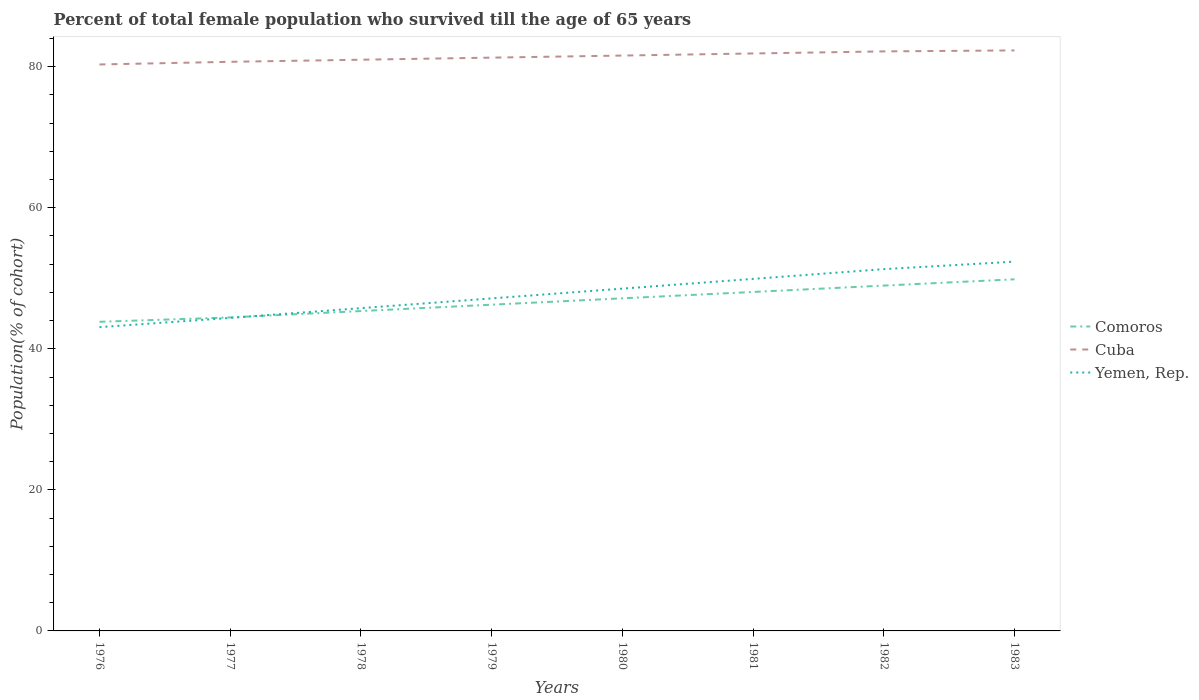Does the line corresponding to Cuba intersect with the line corresponding to Yemen, Rep.?
Provide a short and direct response. No. Across all years, what is the maximum percentage of total female population who survived till the age of 65 years in Comoros?
Offer a terse response. 43.83. In which year was the percentage of total female population who survived till the age of 65 years in Yemen, Rep. maximum?
Offer a very short reply. 1976. What is the total percentage of total female population who survived till the age of 65 years in Cuba in the graph?
Your answer should be compact. -0.3. What is the difference between the highest and the second highest percentage of total female population who survived till the age of 65 years in Comoros?
Your answer should be very brief. 6.03. What is the difference between two consecutive major ticks on the Y-axis?
Make the answer very short. 20. Are the values on the major ticks of Y-axis written in scientific E-notation?
Offer a very short reply. No. Does the graph contain grids?
Provide a succinct answer. No. Where does the legend appear in the graph?
Provide a succinct answer. Center right. How are the legend labels stacked?
Your answer should be very brief. Vertical. What is the title of the graph?
Your response must be concise. Percent of total female population who survived till the age of 65 years. Does "Tonga" appear as one of the legend labels in the graph?
Your answer should be compact. No. What is the label or title of the Y-axis?
Ensure brevity in your answer.  Population(% of cohort). What is the Population(% of cohort) of Comoros in 1976?
Offer a very short reply. 43.83. What is the Population(% of cohort) in Cuba in 1976?
Provide a succinct answer. 80.31. What is the Population(% of cohort) of Yemen, Rep. in 1976?
Provide a succinct answer. 43.07. What is the Population(% of cohort) of Comoros in 1977?
Make the answer very short. 44.45. What is the Population(% of cohort) of Cuba in 1977?
Ensure brevity in your answer.  80.69. What is the Population(% of cohort) of Yemen, Rep. in 1977?
Your response must be concise. 44.38. What is the Population(% of cohort) in Comoros in 1978?
Your answer should be very brief. 45.35. What is the Population(% of cohort) in Cuba in 1978?
Ensure brevity in your answer.  80.99. What is the Population(% of cohort) in Yemen, Rep. in 1978?
Your answer should be compact. 45.76. What is the Population(% of cohort) in Comoros in 1979?
Offer a terse response. 46.25. What is the Population(% of cohort) in Cuba in 1979?
Your response must be concise. 81.28. What is the Population(% of cohort) of Yemen, Rep. in 1979?
Ensure brevity in your answer.  47.15. What is the Population(% of cohort) in Comoros in 1980?
Offer a terse response. 47.16. What is the Population(% of cohort) in Cuba in 1980?
Your answer should be very brief. 81.58. What is the Population(% of cohort) of Yemen, Rep. in 1980?
Ensure brevity in your answer.  48.53. What is the Population(% of cohort) of Comoros in 1981?
Make the answer very short. 48.06. What is the Population(% of cohort) in Cuba in 1981?
Provide a short and direct response. 81.87. What is the Population(% of cohort) of Yemen, Rep. in 1981?
Your answer should be very brief. 49.91. What is the Population(% of cohort) of Comoros in 1982?
Provide a succinct answer. 48.96. What is the Population(% of cohort) of Cuba in 1982?
Provide a short and direct response. 82.17. What is the Population(% of cohort) in Yemen, Rep. in 1982?
Offer a very short reply. 51.3. What is the Population(% of cohort) of Comoros in 1983?
Offer a very short reply. 49.85. What is the Population(% of cohort) of Cuba in 1983?
Keep it short and to the point. 82.31. What is the Population(% of cohort) in Yemen, Rep. in 1983?
Offer a very short reply. 52.35. Across all years, what is the maximum Population(% of cohort) in Comoros?
Keep it short and to the point. 49.85. Across all years, what is the maximum Population(% of cohort) in Cuba?
Your answer should be compact. 82.31. Across all years, what is the maximum Population(% of cohort) of Yemen, Rep.?
Ensure brevity in your answer.  52.35. Across all years, what is the minimum Population(% of cohort) of Comoros?
Offer a terse response. 43.83. Across all years, what is the minimum Population(% of cohort) in Cuba?
Your answer should be compact. 80.31. Across all years, what is the minimum Population(% of cohort) of Yemen, Rep.?
Give a very brief answer. 43.07. What is the total Population(% of cohort) in Comoros in the graph?
Give a very brief answer. 373.92. What is the total Population(% of cohort) of Cuba in the graph?
Offer a terse response. 651.2. What is the total Population(% of cohort) of Yemen, Rep. in the graph?
Give a very brief answer. 382.45. What is the difference between the Population(% of cohort) of Comoros in 1976 and that in 1977?
Your answer should be very brief. -0.62. What is the difference between the Population(% of cohort) in Cuba in 1976 and that in 1977?
Offer a terse response. -0.38. What is the difference between the Population(% of cohort) of Yemen, Rep. in 1976 and that in 1977?
Keep it short and to the point. -1.31. What is the difference between the Population(% of cohort) of Comoros in 1976 and that in 1978?
Provide a succinct answer. -1.52. What is the difference between the Population(% of cohort) of Cuba in 1976 and that in 1978?
Keep it short and to the point. -0.67. What is the difference between the Population(% of cohort) of Yemen, Rep. in 1976 and that in 1978?
Give a very brief answer. -2.69. What is the difference between the Population(% of cohort) in Comoros in 1976 and that in 1979?
Ensure brevity in your answer.  -2.43. What is the difference between the Population(% of cohort) of Cuba in 1976 and that in 1979?
Your response must be concise. -0.97. What is the difference between the Population(% of cohort) of Yemen, Rep. in 1976 and that in 1979?
Provide a succinct answer. -4.08. What is the difference between the Population(% of cohort) in Comoros in 1976 and that in 1980?
Give a very brief answer. -3.33. What is the difference between the Population(% of cohort) of Cuba in 1976 and that in 1980?
Provide a short and direct response. -1.26. What is the difference between the Population(% of cohort) of Yemen, Rep. in 1976 and that in 1980?
Keep it short and to the point. -5.46. What is the difference between the Population(% of cohort) in Comoros in 1976 and that in 1981?
Ensure brevity in your answer.  -4.23. What is the difference between the Population(% of cohort) in Cuba in 1976 and that in 1981?
Offer a very short reply. -1.56. What is the difference between the Population(% of cohort) of Yemen, Rep. in 1976 and that in 1981?
Your response must be concise. -6.84. What is the difference between the Population(% of cohort) in Comoros in 1976 and that in 1982?
Your response must be concise. -5.13. What is the difference between the Population(% of cohort) of Cuba in 1976 and that in 1982?
Keep it short and to the point. -1.85. What is the difference between the Population(% of cohort) of Yemen, Rep. in 1976 and that in 1982?
Provide a short and direct response. -8.23. What is the difference between the Population(% of cohort) of Comoros in 1976 and that in 1983?
Make the answer very short. -6.03. What is the difference between the Population(% of cohort) in Cuba in 1976 and that in 1983?
Ensure brevity in your answer.  -1.99. What is the difference between the Population(% of cohort) in Yemen, Rep. in 1976 and that in 1983?
Give a very brief answer. -9.28. What is the difference between the Population(% of cohort) of Comoros in 1977 and that in 1978?
Your response must be concise. -0.9. What is the difference between the Population(% of cohort) in Cuba in 1977 and that in 1978?
Make the answer very short. -0.3. What is the difference between the Population(% of cohort) of Yemen, Rep. in 1977 and that in 1978?
Your answer should be very brief. -1.38. What is the difference between the Population(% of cohort) in Comoros in 1977 and that in 1979?
Your answer should be very brief. -1.81. What is the difference between the Population(% of cohort) of Cuba in 1977 and that in 1979?
Your answer should be compact. -0.59. What is the difference between the Population(% of cohort) in Yemen, Rep. in 1977 and that in 1979?
Your answer should be compact. -2.77. What is the difference between the Population(% of cohort) of Comoros in 1977 and that in 1980?
Offer a very short reply. -2.71. What is the difference between the Population(% of cohort) in Cuba in 1977 and that in 1980?
Keep it short and to the point. -0.89. What is the difference between the Population(% of cohort) of Yemen, Rep. in 1977 and that in 1980?
Offer a terse response. -4.15. What is the difference between the Population(% of cohort) of Comoros in 1977 and that in 1981?
Your response must be concise. -3.61. What is the difference between the Population(% of cohort) of Cuba in 1977 and that in 1981?
Ensure brevity in your answer.  -1.18. What is the difference between the Population(% of cohort) of Yemen, Rep. in 1977 and that in 1981?
Ensure brevity in your answer.  -5.53. What is the difference between the Population(% of cohort) in Comoros in 1977 and that in 1982?
Offer a very short reply. -4.51. What is the difference between the Population(% of cohort) in Cuba in 1977 and that in 1982?
Make the answer very short. -1.48. What is the difference between the Population(% of cohort) in Yemen, Rep. in 1977 and that in 1982?
Ensure brevity in your answer.  -6.92. What is the difference between the Population(% of cohort) in Comoros in 1977 and that in 1983?
Your answer should be compact. -5.41. What is the difference between the Population(% of cohort) of Cuba in 1977 and that in 1983?
Provide a short and direct response. -1.62. What is the difference between the Population(% of cohort) in Yemen, Rep. in 1977 and that in 1983?
Your response must be concise. -7.97. What is the difference between the Population(% of cohort) of Comoros in 1978 and that in 1979?
Keep it short and to the point. -0.9. What is the difference between the Population(% of cohort) in Cuba in 1978 and that in 1979?
Give a very brief answer. -0.3. What is the difference between the Population(% of cohort) in Yemen, Rep. in 1978 and that in 1979?
Make the answer very short. -1.38. What is the difference between the Population(% of cohort) of Comoros in 1978 and that in 1980?
Offer a terse response. -1.81. What is the difference between the Population(% of cohort) in Cuba in 1978 and that in 1980?
Keep it short and to the point. -0.59. What is the difference between the Population(% of cohort) in Yemen, Rep. in 1978 and that in 1980?
Offer a very short reply. -2.77. What is the difference between the Population(% of cohort) of Comoros in 1978 and that in 1981?
Offer a very short reply. -2.71. What is the difference between the Population(% of cohort) of Cuba in 1978 and that in 1981?
Your answer should be compact. -0.89. What is the difference between the Population(% of cohort) in Yemen, Rep. in 1978 and that in 1981?
Your answer should be very brief. -4.15. What is the difference between the Population(% of cohort) of Comoros in 1978 and that in 1982?
Keep it short and to the point. -3.61. What is the difference between the Population(% of cohort) in Cuba in 1978 and that in 1982?
Provide a succinct answer. -1.18. What is the difference between the Population(% of cohort) in Yemen, Rep. in 1978 and that in 1982?
Keep it short and to the point. -5.53. What is the difference between the Population(% of cohort) of Comoros in 1978 and that in 1983?
Make the answer very short. -4.5. What is the difference between the Population(% of cohort) in Cuba in 1978 and that in 1983?
Your answer should be very brief. -1.32. What is the difference between the Population(% of cohort) in Yemen, Rep. in 1978 and that in 1983?
Keep it short and to the point. -6.59. What is the difference between the Population(% of cohort) in Comoros in 1979 and that in 1980?
Your response must be concise. -0.9. What is the difference between the Population(% of cohort) of Cuba in 1979 and that in 1980?
Your response must be concise. -0.3. What is the difference between the Population(% of cohort) in Yemen, Rep. in 1979 and that in 1980?
Give a very brief answer. -1.38. What is the difference between the Population(% of cohort) of Comoros in 1979 and that in 1981?
Ensure brevity in your answer.  -1.81. What is the difference between the Population(% of cohort) of Cuba in 1979 and that in 1981?
Ensure brevity in your answer.  -0.59. What is the difference between the Population(% of cohort) in Yemen, Rep. in 1979 and that in 1981?
Make the answer very short. -2.77. What is the difference between the Population(% of cohort) of Comoros in 1979 and that in 1982?
Give a very brief answer. -2.71. What is the difference between the Population(% of cohort) in Cuba in 1979 and that in 1982?
Your answer should be very brief. -0.89. What is the difference between the Population(% of cohort) in Yemen, Rep. in 1979 and that in 1982?
Keep it short and to the point. -4.15. What is the difference between the Population(% of cohort) in Comoros in 1979 and that in 1983?
Provide a short and direct response. -3.6. What is the difference between the Population(% of cohort) of Cuba in 1979 and that in 1983?
Keep it short and to the point. -1.02. What is the difference between the Population(% of cohort) of Yemen, Rep. in 1979 and that in 1983?
Offer a very short reply. -5.21. What is the difference between the Population(% of cohort) in Comoros in 1980 and that in 1981?
Provide a succinct answer. -0.9. What is the difference between the Population(% of cohort) of Cuba in 1980 and that in 1981?
Give a very brief answer. -0.3. What is the difference between the Population(% of cohort) of Yemen, Rep. in 1980 and that in 1981?
Your answer should be very brief. -1.38. What is the difference between the Population(% of cohort) in Comoros in 1980 and that in 1982?
Give a very brief answer. -1.81. What is the difference between the Population(% of cohort) in Cuba in 1980 and that in 1982?
Make the answer very short. -0.59. What is the difference between the Population(% of cohort) of Yemen, Rep. in 1980 and that in 1982?
Keep it short and to the point. -2.77. What is the difference between the Population(% of cohort) in Comoros in 1980 and that in 1983?
Your answer should be compact. -2.7. What is the difference between the Population(% of cohort) in Cuba in 1980 and that in 1983?
Offer a terse response. -0.73. What is the difference between the Population(% of cohort) in Yemen, Rep. in 1980 and that in 1983?
Your answer should be very brief. -3.82. What is the difference between the Population(% of cohort) of Comoros in 1981 and that in 1982?
Offer a very short reply. -0.9. What is the difference between the Population(% of cohort) in Cuba in 1981 and that in 1982?
Give a very brief answer. -0.3. What is the difference between the Population(% of cohort) in Yemen, Rep. in 1981 and that in 1982?
Give a very brief answer. -1.38. What is the difference between the Population(% of cohort) in Comoros in 1981 and that in 1983?
Give a very brief answer. -1.8. What is the difference between the Population(% of cohort) of Cuba in 1981 and that in 1983?
Offer a very short reply. -0.43. What is the difference between the Population(% of cohort) of Yemen, Rep. in 1981 and that in 1983?
Offer a very short reply. -2.44. What is the difference between the Population(% of cohort) of Comoros in 1982 and that in 1983?
Provide a short and direct response. -0.89. What is the difference between the Population(% of cohort) in Cuba in 1982 and that in 1983?
Give a very brief answer. -0.14. What is the difference between the Population(% of cohort) in Yemen, Rep. in 1982 and that in 1983?
Make the answer very short. -1.06. What is the difference between the Population(% of cohort) in Comoros in 1976 and the Population(% of cohort) in Cuba in 1977?
Provide a short and direct response. -36.86. What is the difference between the Population(% of cohort) of Comoros in 1976 and the Population(% of cohort) of Yemen, Rep. in 1977?
Keep it short and to the point. -0.55. What is the difference between the Population(% of cohort) in Cuba in 1976 and the Population(% of cohort) in Yemen, Rep. in 1977?
Your answer should be very brief. 35.93. What is the difference between the Population(% of cohort) of Comoros in 1976 and the Population(% of cohort) of Cuba in 1978?
Your response must be concise. -37.16. What is the difference between the Population(% of cohort) in Comoros in 1976 and the Population(% of cohort) in Yemen, Rep. in 1978?
Keep it short and to the point. -1.94. What is the difference between the Population(% of cohort) in Cuba in 1976 and the Population(% of cohort) in Yemen, Rep. in 1978?
Offer a terse response. 34.55. What is the difference between the Population(% of cohort) in Comoros in 1976 and the Population(% of cohort) in Cuba in 1979?
Provide a succinct answer. -37.45. What is the difference between the Population(% of cohort) in Comoros in 1976 and the Population(% of cohort) in Yemen, Rep. in 1979?
Provide a succinct answer. -3.32. What is the difference between the Population(% of cohort) in Cuba in 1976 and the Population(% of cohort) in Yemen, Rep. in 1979?
Provide a succinct answer. 33.17. What is the difference between the Population(% of cohort) in Comoros in 1976 and the Population(% of cohort) in Cuba in 1980?
Your answer should be very brief. -37.75. What is the difference between the Population(% of cohort) in Comoros in 1976 and the Population(% of cohort) in Yemen, Rep. in 1980?
Provide a succinct answer. -4.7. What is the difference between the Population(% of cohort) of Cuba in 1976 and the Population(% of cohort) of Yemen, Rep. in 1980?
Offer a terse response. 31.78. What is the difference between the Population(% of cohort) in Comoros in 1976 and the Population(% of cohort) in Cuba in 1981?
Your answer should be compact. -38.04. What is the difference between the Population(% of cohort) in Comoros in 1976 and the Population(% of cohort) in Yemen, Rep. in 1981?
Make the answer very short. -6.09. What is the difference between the Population(% of cohort) of Cuba in 1976 and the Population(% of cohort) of Yemen, Rep. in 1981?
Offer a very short reply. 30.4. What is the difference between the Population(% of cohort) in Comoros in 1976 and the Population(% of cohort) in Cuba in 1982?
Keep it short and to the point. -38.34. What is the difference between the Population(% of cohort) in Comoros in 1976 and the Population(% of cohort) in Yemen, Rep. in 1982?
Provide a succinct answer. -7.47. What is the difference between the Population(% of cohort) in Cuba in 1976 and the Population(% of cohort) in Yemen, Rep. in 1982?
Provide a succinct answer. 29.02. What is the difference between the Population(% of cohort) of Comoros in 1976 and the Population(% of cohort) of Cuba in 1983?
Your answer should be very brief. -38.48. What is the difference between the Population(% of cohort) in Comoros in 1976 and the Population(% of cohort) in Yemen, Rep. in 1983?
Keep it short and to the point. -8.53. What is the difference between the Population(% of cohort) in Cuba in 1976 and the Population(% of cohort) in Yemen, Rep. in 1983?
Ensure brevity in your answer.  27.96. What is the difference between the Population(% of cohort) in Comoros in 1977 and the Population(% of cohort) in Cuba in 1978?
Your answer should be compact. -36.54. What is the difference between the Population(% of cohort) in Comoros in 1977 and the Population(% of cohort) in Yemen, Rep. in 1978?
Offer a terse response. -1.31. What is the difference between the Population(% of cohort) in Cuba in 1977 and the Population(% of cohort) in Yemen, Rep. in 1978?
Keep it short and to the point. 34.93. What is the difference between the Population(% of cohort) in Comoros in 1977 and the Population(% of cohort) in Cuba in 1979?
Make the answer very short. -36.83. What is the difference between the Population(% of cohort) in Comoros in 1977 and the Population(% of cohort) in Yemen, Rep. in 1979?
Your answer should be compact. -2.7. What is the difference between the Population(% of cohort) of Cuba in 1977 and the Population(% of cohort) of Yemen, Rep. in 1979?
Make the answer very short. 33.54. What is the difference between the Population(% of cohort) in Comoros in 1977 and the Population(% of cohort) in Cuba in 1980?
Keep it short and to the point. -37.13. What is the difference between the Population(% of cohort) of Comoros in 1977 and the Population(% of cohort) of Yemen, Rep. in 1980?
Your answer should be compact. -4.08. What is the difference between the Population(% of cohort) in Cuba in 1977 and the Population(% of cohort) in Yemen, Rep. in 1980?
Your response must be concise. 32.16. What is the difference between the Population(% of cohort) in Comoros in 1977 and the Population(% of cohort) in Cuba in 1981?
Keep it short and to the point. -37.42. What is the difference between the Population(% of cohort) of Comoros in 1977 and the Population(% of cohort) of Yemen, Rep. in 1981?
Your answer should be very brief. -5.46. What is the difference between the Population(% of cohort) in Cuba in 1977 and the Population(% of cohort) in Yemen, Rep. in 1981?
Make the answer very short. 30.78. What is the difference between the Population(% of cohort) in Comoros in 1977 and the Population(% of cohort) in Cuba in 1982?
Offer a terse response. -37.72. What is the difference between the Population(% of cohort) in Comoros in 1977 and the Population(% of cohort) in Yemen, Rep. in 1982?
Your answer should be compact. -6.85. What is the difference between the Population(% of cohort) of Cuba in 1977 and the Population(% of cohort) of Yemen, Rep. in 1982?
Offer a very short reply. 29.39. What is the difference between the Population(% of cohort) of Comoros in 1977 and the Population(% of cohort) of Cuba in 1983?
Offer a terse response. -37.86. What is the difference between the Population(% of cohort) in Comoros in 1977 and the Population(% of cohort) in Yemen, Rep. in 1983?
Make the answer very short. -7.9. What is the difference between the Population(% of cohort) of Cuba in 1977 and the Population(% of cohort) of Yemen, Rep. in 1983?
Your response must be concise. 28.34. What is the difference between the Population(% of cohort) in Comoros in 1978 and the Population(% of cohort) in Cuba in 1979?
Ensure brevity in your answer.  -35.93. What is the difference between the Population(% of cohort) of Comoros in 1978 and the Population(% of cohort) of Yemen, Rep. in 1979?
Offer a very short reply. -1.79. What is the difference between the Population(% of cohort) of Cuba in 1978 and the Population(% of cohort) of Yemen, Rep. in 1979?
Make the answer very short. 33.84. What is the difference between the Population(% of cohort) of Comoros in 1978 and the Population(% of cohort) of Cuba in 1980?
Offer a terse response. -36.23. What is the difference between the Population(% of cohort) of Comoros in 1978 and the Population(% of cohort) of Yemen, Rep. in 1980?
Provide a short and direct response. -3.18. What is the difference between the Population(% of cohort) of Cuba in 1978 and the Population(% of cohort) of Yemen, Rep. in 1980?
Offer a terse response. 32.46. What is the difference between the Population(% of cohort) in Comoros in 1978 and the Population(% of cohort) in Cuba in 1981?
Provide a short and direct response. -36.52. What is the difference between the Population(% of cohort) in Comoros in 1978 and the Population(% of cohort) in Yemen, Rep. in 1981?
Ensure brevity in your answer.  -4.56. What is the difference between the Population(% of cohort) of Cuba in 1978 and the Population(% of cohort) of Yemen, Rep. in 1981?
Your response must be concise. 31.07. What is the difference between the Population(% of cohort) in Comoros in 1978 and the Population(% of cohort) in Cuba in 1982?
Offer a terse response. -36.82. What is the difference between the Population(% of cohort) in Comoros in 1978 and the Population(% of cohort) in Yemen, Rep. in 1982?
Your answer should be very brief. -5.94. What is the difference between the Population(% of cohort) in Cuba in 1978 and the Population(% of cohort) in Yemen, Rep. in 1982?
Provide a succinct answer. 29.69. What is the difference between the Population(% of cohort) of Comoros in 1978 and the Population(% of cohort) of Cuba in 1983?
Give a very brief answer. -36.95. What is the difference between the Population(% of cohort) in Comoros in 1978 and the Population(% of cohort) in Yemen, Rep. in 1983?
Provide a short and direct response. -7. What is the difference between the Population(% of cohort) in Cuba in 1978 and the Population(% of cohort) in Yemen, Rep. in 1983?
Give a very brief answer. 28.63. What is the difference between the Population(% of cohort) in Comoros in 1979 and the Population(% of cohort) in Cuba in 1980?
Ensure brevity in your answer.  -35.32. What is the difference between the Population(% of cohort) in Comoros in 1979 and the Population(% of cohort) in Yemen, Rep. in 1980?
Make the answer very short. -2.28. What is the difference between the Population(% of cohort) in Cuba in 1979 and the Population(% of cohort) in Yemen, Rep. in 1980?
Make the answer very short. 32.75. What is the difference between the Population(% of cohort) of Comoros in 1979 and the Population(% of cohort) of Cuba in 1981?
Give a very brief answer. -35.62. What is the difference between the Population(% of cohort) of Comoros in 1979 and the Population(% of cohort) of Yemen, Rep. in 1981?
Your answer should be compact. -3.66. What is the difference between the Population(% of cohort) in Cuba in 1979 and the Population(% of cohort) in Yemen, Rep. in 1981?
Offer a terse response. 31.37. What is the difference between the Population(% of cohort) of Comoros in 1979 and the Population(% of cohort) of Cuba in 1982?
Your response must be concise. -35.91. What is the difference between the Population(% of cohort) in Comoros in 1979 and the Population(% of cohort) in Yemen, Rep. in 1982?
Make the answer very short. -5.04. What is the difference between the Population(% of cohort) in Cuba in 1979 and the Population(% of cohort) in Yemen, Rep. in 1982?
Keep it short and to the point. 29.99. What is the difference between the Population(% of cohort) of Comoros in 1979 and the Population(% of cohort) of Cuba in 1983?
Provide a succinct answer. -36.05. What is the difference between the Population(% of cohort) in Comoros in 1979 and the Population(% of cohort) in Yemen, Rep. in 1983?
Provide a short and direct response. -6.1. What is the difference between the Population(% of cohort) of Cuba in 1979 and the Population(% of cohort) of Yemen, Rep. in 1983?
Keep it short and to the point. 28.93. What is the difference between the Population(% of cohort) of Comoros in 1980 and the Population(% of cohort) of Cuba in 1981?
Offer a terse response. -34.72. What is the difference between the Population(% of cohort) in Comoros in 1980 and the Population(% of cohort) in Yemen, Rep. in 1981?
Keep it short and to the point. -2.76. What is the difference between the Population(% of cohort) of Cuba in 1980 and the Population(% of cohort) of Yemen, Rep. in 1981?
Keep it short and to the point. 31.66. What is the difference between the Population(% of cohort) in Comoros in 1980 and the Population(% of cohort) in Cuba in 1982?
Offer a very short reply. -35.01. What is the difference between the Population(% of cohort) of Comoros in 1980 and the Population(% of cohort) of Yemen, Rep. in 1982?
Offer a terse response. -4.14. What is the difference between the Population(% of cohort) in Cuba in 1980 and the Population(% of cohort) in Yemen, Rep. in 1982?
Your answer should be compact. 30.28. What is the difference between the Population(% of cohort) in Comoros in 1980 and the Population(% of cohort) in Cuba in 1983?
Ensure brevity in your answer.  -35.15. What is the difference between the Population(% of cohort) of Comoros in 1980 and the Population(% of cohort) of Yemen, Rep. in 1983?
Provide a succinct answer. -5.2. What is the difference between the Population(% of cohort) in Cuba in 1980 and the Population(% of cohort) in Yemen, Rep. in 1983?
Ensure brevity in your answer.  29.22. What is the difference between the Population(% of cohort) of Comoros in 1981 and the Population(% of cohort) of Cuba in 1982?
Provide a succinct answer. -34.11. What is the difference between the Population(% of cohort) of Comoros in 1981 and the Population(% of cohort) of Yemen, Rep. in 1982?
Keep it short and to the point. -3.24. What is the difference between the Population(% of cohort) of Cuba in 1981 and the Population(% of cohort) of Yemen, Rep. in 1982?
Give a very brief answer. 30.58. What is the difference between the Population(% of cohort) of Comoros in 1981 and the Population(% of cohort) of Cuba in 1983?
Your response must be concise. -34.25. What is the difference between the Population(% of cohort) in Comoros in 1981 and the Population(% of cohort) in Yemen, Rep. in 1983?
Keep it short and to the point. -4.29. What is the difference between the Population(% of cohort) in Cuba in 1981 and the Population(% of cohort) in Yemen, Rep. in 1983?
Ensure brevity in your answer.  29.52. What is the difference between the Population(% of cohort) in Comoros in 1982 and the Population(% of cohort) in Cuba in 1983?
Offer a very short reply. -33.34. What is the difference between the Population(% of cohort) of Comoros in 1982 and the Population(% of cohort) of Yemen, Rep. in 1983?
Ensure brevity in your answer.  -3.39. What is the difference between the Population(% of cohort) in Cuba in 1982 and the Population(% of cohort) in Yemen, Rep. in 1983?
Ensure brevity in your answer.  29.81. What is the average Population(% of cohort) of Comoros per year?
Provide a succinct answer. 46.74. What is the average Population(% of cohort) of Cuba per year?
Your answer should be very brief. 81.4. What is the average Population(% of cohort) in Yemen, Rep. per year?
Keep it short and to the point. 47.81. In the year 1976, what is the difference between the Population(% of cohort) of Comoros and Population(% of cohort) of Cuba?
Give a very brief answer. -36.49. In the year 1976, what is the difference between the Population(% of cohort) of Comoros and Population(% of cohort) of Yemen, Rep.?
Keep it short and to the point. 0.76. In the year 1976, what is the difference between the Population(% of cohort) of Cuba and Population(% of cohort) of Yemen, Rep.?
Your answer should be compact. 37.24. In the year 1977, what is the difference between the Population(% of cohort) of Comoros and Population(% of cohort) of Cuba?
Your answer should be compact. -36.24. In the year 1977, what is the difference between the Population(% of cohort) of Comoros and Population(% of cohort) of Yemen, Rep.?
Make the answer very short. 0.07. In the year 1977, what is the difference between the Population(% of cohort) in Cuba and Population(% of cohort) in Yemen, Rep.?
Offer a very short reply. 36.31. In the year 1978, what is the difference between the Population(% of cohort) in Comoros and Population(% of cohort) in Cuba?
Ensure brevity in your answer.  -35.63. In the year 1978, what is the difference between the Population(% of cohort) of Comoros and Population(% of cohort) of Yemen, Rep.?
Offer a terse response. -0.41. In the year 1978, what is the difference between the Population(% of cohort) in Cuba and Population(% of cohort) in Yemen, Rep.?
Offer a very short reply. 35.22. In the year 1979, what is the difference between the Population(% of cohort) in Comoros and Population(% of cohort) in Cuba?
Offer a very short reply. -35.03. In the year 1979, what is the difference between the Population(% of cohort) of Comoros and Population(% of cohort) of Yemen, Rep.?
Your answer should be very brief. -0.89. In the year 1979, what is the difference between the Population(% of cohort) in Cuba and Population(% of cohort) in Yemen, Rep.?
Your answer should be compact. 34.13. In the year 1980, what is the difference between the Population(% of cohort) of Comoros and Population(% of cohort) of Cuba?
Keep it short and to the point. -34.42. In the year 1980, what is the difference between the Population(% of cohort) in Comoros and Population(% of cohort) in Yemen, Rep.?
Your answer should be compact. -1.37. In the year 1980, what is the difference between the Population(% of cohort) of Cuba and Population(% of cohort) of Yemen, Rep.?
Keep it short and to the point. 33.05. In the year 1981, what is the difference between the Population(% of cohort) of Comoros and Population(% of cohort) of Cuba?
Offer a very short reply. -33.81. In the year 1981, what is the difference between the Population(% of cohort) of Comoros and Population(% of cohort) of Yemen, Rep.?
Ensure brevity in your answer.  -1.85. In the year 1981, what is the difference between the Population(% of cohort) in Cuba and Population(% of cohort) in Yemen, Rep.?
Give a very brief answer. 31.96. In the year 1982, what is the difference between the Population(% of cohort) in Comoros and Population(% of cohort) in Cuba?
Your answer should be compact. -33.21. In the year 1982, what is the difference between the Population(% of cohort) of Comoros and Population(% of cohort) of Yemen, Rep.?
Your answer should be very brief. -2.33. In the year 1982, what is the difference between the Population(% of cohort) in Cuba and Population(% of cohort) in Yemen, Rep.?
Provide a short and direct response. 30.87. In the year 1983, what is the difference between the Population(% of cohort) in Comoros and Population(% of cohort) in Cuba?
Give a very brief answer. -32.45. In the year 1983, what is the difference between the Population(% of cohort) in Comoros and Population(% of cohort) in Yemen, Rep.?
Provide a succinct answer. -2.5. In the year 1983, what is the difference between the Population(% of cohort) in Cuba and Population(% of cohort) in Yemen, Rep.?
Provide a short and direct response. 29.95. What is the ratio of the Population(% of cohort) of Comoros in 1976 to that in 1977?
Your response must be concise. 0.99. What is the ratio of the Population(% of cohort) of Yemen, Rep. in 1976 to that in 1977?
Give a very brief answer. 0.97. What is the ratio of the Population(% of cohort) in Comoros in 1976 to that in 1978?
Your response must be concise. 0.97. What is the ratio of the Population(% of cohort) of Yemen, Rep. in 1976 to that in 1978?
Your response must be concise. 0.94. What is the ratio of the Population(% of cohort) in Comoros in 1976 to that in 1979?
Keep it short and to the point. 0.95. What is the ratio of the Population(% of cohort) of Cuba in 1976 to that in 1979?
Provide a short and direct response. 0.99. What is the ratio of the Population(% of cohort) in Yemen, Rep. in 1976 to that in 1979?
Your answer should be compact. 0.91. What is the ratio of the Population(% of cohort) of Comoros in 1976 to that in 1980?
Offer a terse response. 0.93. What is the ratio of the Population(% of cohort) of Cuba in 1976 to that in 1980?
Provide a short and direct response. 0.98. What is the ratio of the Population(% of cohort) in Yemen, Rep. in 1976 to that in 1980?
Ensure brevity in your answer.  0.89. What is the ratio of the Population(% of cohort) of Comoros in 1976 to that in 1981?
Your answer should be compact. 0.91. What is the ratio of the Population(% of cohort) in Cuba in 1976 to that in 1981?
Offer a terse response. 0.98. What is the ratio of the Population(% of cohort) of Yemen, Rep. in 1976 to that in 1981?
Keep it short and to the point. 0.86. What is the ratio of the Population(% of cohort) in Comoros in 1976 to that in 1982?
Provide a succinct answer. 0.9. What is the ratio of the Population(% of cohort) of Cuba in 1976 to that in 1982?
Make the answer very short. 0.98. What is the ratio of the Population(% of cohort) of Yemen, Rep. in 1976 to that in 1982?
Your answer should be very brief. 0.84. What is the ratio of the Population(% of cohort) in Comoros in 1976 to that in 1983?
Make the answer very short. 0.88. What is the ratio of the Population(% of cohort) in Cuba in 1976 to that in 1983?
Your answer should be compact. 0.98. What is the ratio of the Population(% of cohort) of Yemen, Rep. in 1976 to that in 1983?
Your answer should be compact. 0.82. What is the ratio of the Population(% of cohort) of Comoros in 1977 to that in 1978?
Offer a very short reply. 0.98. What is the ratio of the Population(% of cohort) of Cuba in 1977 to that in 1978?
Your response must be concise. 1. What is the ratio of the Population(% of cohort) in Yemen, Rep. in 1977 to that in 1978?
Provide a short and direct response. 0.97. What is the ratio of the Population(% of cohort) of Comoros in 1977 to that in 1979?
Offer a very short reply. 0.96. What is the ratio of the Population(% of cohort) in Yemen, Rep. in 1977 to that in 1979?
Your answer should be compact. 0.94. What is the ratio of the Population(% of cohort) of Comoros in 1977 to that in 1980?
Offer a terse response. 0.94. What is the ratio of the Population(% of cohort) in Cuba in 1977 to that in 1980?
Your answer should be compact. 0.99. What is the ratio of the Population(% of cohort) of Yemen, Rep. in 1977 to that in 1980?
Provide a short and direct response. 0.91. What is the ratio of the Population(% of cohort) in Comoros in 1977 to that in 1981?
Provide a short and direct response. 0.92. What is the ratio of the Population(% of cohort) of Cuba in 1977 to that in 1981?
Your answer should be very brief. 0.99. What is the ratio of the Population(% of cohort) of Yemen, Rep. in 1977 to that in 1981?
Your answer should be very brief. 0.89. What is the ratio of the Population(% of cohort) of Comoros in 1977 to that in 1982?
Offer a terse response. 0.91. What is the ratio of the Population(% of cohort) in Yemen, Rep. in 1977 to that in 1982?
Your answer should be very brief. 0.87. What is the ratio of the Population(% of cohort) in Comoros in 1977 to that in 1983?
Keep it short and to the point. 0.89. What is the ratio of the Population(% of cohort) of Cuba in 1977 to that in 1983?
Give a very brief answer. 0.98. What is the ratio of the Population(% of cohort) of Yemen, Rep. in 1977 to that in 1983?
Offer a terse response. 0.85. What is the ratio of the Population(% of cohort) of Comoros in 1978 to that in 1979?
Your answer should be very brief. 0.98. What is the ratio of the Population(% of cohort) of Yemen, Rep. in 1978 to that in 1979?
Your response must be concise. 0.97. What is the ratio of the Population(% of cohort) of Comoros in 1978 to that in 1980?
Give a very brief answer. 0.96. What is the ratio of the Population(% of cohort) of Cuba in 1978 to that in 1980?
Ensure brevity in your answer.  0.99. What is the ratio of the Population(% of cohort) in Yemen, Rep. in 1978 to that in 1980?
Provide a short and direct response. 0.94. What is the ratio of the Population(% of cohort) in Comoros in 1978 to that in 1981?
Offer a very short reply. 0.94. What is the ratio of the Population(% of cohort) in Cuba in 1978 to that in 1981?
Give a very brief answer. 0.99. What is the ratio of the Population(% of cohort) of Yemen, Rep. in 1978 to that in 1981?
Offer a very short reply. 0.92. What is the ratio of the Population(% of cohort) in Comoros in 1978 to that in 1982?
Provide a succinct answer. 0.93. What is the ratio of the Population(% of cohort) in Cuba in 1978 to that in 1982?
Provide a succinct answer. 0.99. What is the ratio of the Population(% of cohort) of Yemen, Rep. in 1978 to that in 1982?
Make the answer very short. 0.89. What is the ratio of the Population(% of cohort) of Comoros in 1978 to that in 1983?
Offer a very short reply. 0.91. What is the ratio of the Population(% of cohort) in Cuba in 1978 to that in 1983?
Offer a terse response. 0.98. What is the ratio of the Population(% of cohort) of Yemen, Rep. in 1978 to that in 1983?
Your answer should be compact. 0.87. What is the ratio of the Population(% of cohort) in Comoros in 1979 to that in 1980?
Provide a succinct answer. 0.98. What is the ratio of the Population(% of cohort) of Cuba in 1979 to that in 1980?
Your response must be concise. 1. What is the ratio of the Population(% of cohort) in Yemen, Rep. in 1979 to that in 1980?
Keep it short and to the point. 0.97. What is the ratio of the Population(% of cohort) in Comoros in 1979 to that in 1981?
Your response must be concise. 0.96. What is the ratio of the Population(% of cohort) of Yemen, Rep. in 1979 to that in 1981?
Keep it short and to the point. 0.94. What is the ratio of the Population(% of cohort) of Comoros in 1979 to that in 1982?
Your answer should be compact. 0.94. What is the ratio of the Population(% of cohort) in Yemen, Rep. in 1979 to that in 1982?
Ensure brevity in your answer.  0.92. What is the ratio of the Population(% of cohort) of Comoros in 1979 to that in 1983?
Your answer should be compact. 0.93. What is the ratio of the Population(% of cohort) in Cuba in 1979 to that in 1983?
Your answer should be compact. 0.99. What is the ratio of the Population(% of cohort) in Yemen, Rep. in 1979 to that in 1983?
Provide a succinct answer. 0.9. What is the ratio of the Population(% of cohort) in Comoros in 1980 to that in 1981?
Provide a short and direct response. 0.98. What is the ratio of the Population(% of cohort) in Cuba in 1980 to that in 1981?
Your response must be concise. 1. What is the ratio of the Population(% of cohort) in Yemen, Rep. in 1980 to that in 1981?
Provide a succinct answer. 0.97. What is the ratio of the Population(% of cohort) in Comoros in 1980 to that in 1982?
Offer a very short reply. 0.96. What is the ratio of the Population(% of cohort) in Yemen, Rep. in 1980 to that in 1982?
Your answer should be compact. 0.95. What is the ratio of the Population(% of cohort) of Comoros in 1980 to that in 1983?
Your answer should be very brief. 0.95. What is the ratio of the Population(% of cohort) in Cuba in 1980 to that in 1983?
Your response must be concise. 0.99. What is the ratio of the Population(% of cohort) of Yemen, Rep. in 1980 to that in 1983?
Make the answer very short. 0.93. What is the ratio of the Population(% of cohort) of Comoros in 1981 to that in 1982?
Offer a terse response. 0.98. What is the ratio of the Population(% of cohort) in Comoros in 1981 to that in 1983?
Give a very brief answer. 0.96. What is the ratio of the Population(% of cohort) of Yemen, Rep. in 1981 to that in 1983?
Your answer should be compact. 0.95. What is the ratio of the Population(% of cohort) of Comoros in 1982 to that in 1983?
Your answer should be very brief. 0.98. What is the ratio of the Population(% of cohort) in Yemen, Rep. in 1982 to that in 1983?
Your response must be concise. 0.98. What is the difference between the highest and the second highest Population(% of cohort) of Comoros?
Ensure brevity in your answer.  0.89. What is the difference between the highest and the second highest Population(% of cohort) of Cuba?
Make the answer very short. 0.14. What is the difference between the highest and the second highest Population(% of cohort) of Yemen, Rep.?
Your answer should be very brief. 1.06. What is the difference between the highest and the lowest Population(% of cohort) in Comoros?
Provide a succinct answer. 6.03. What is the difference between the highest and the lowest Population(% of cohort) in Cuba?
Keep it short and to the point. 1.99. What is the difference between the highest and the lowest Population(% of cohort) of Yemen, Rep.?
Offer a terse response. 9.28. 